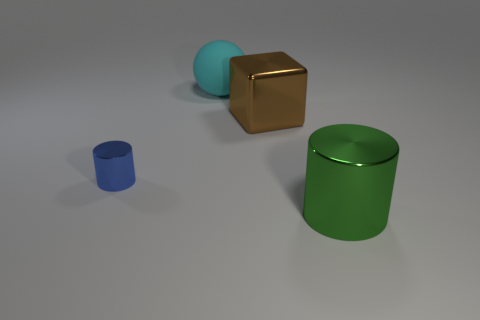Add 2 brown things. How many objects exist? 6 Add 1 blue rubber cylinders. How many blue rubber cylinders exist? 1 Subtract 0 purple balls. How many objects are left? 4 Subtract all spheres. How many objects are left? 3 Subtract all cyan cylinders. Subtract all yellow spheres. How many cylinders are left? 2 Subtract all blue things. Subtract all cyan rubber balls. How many objects are left? 2 Add 4 big cyan spheres. How many big cyan spheres are left? 5 